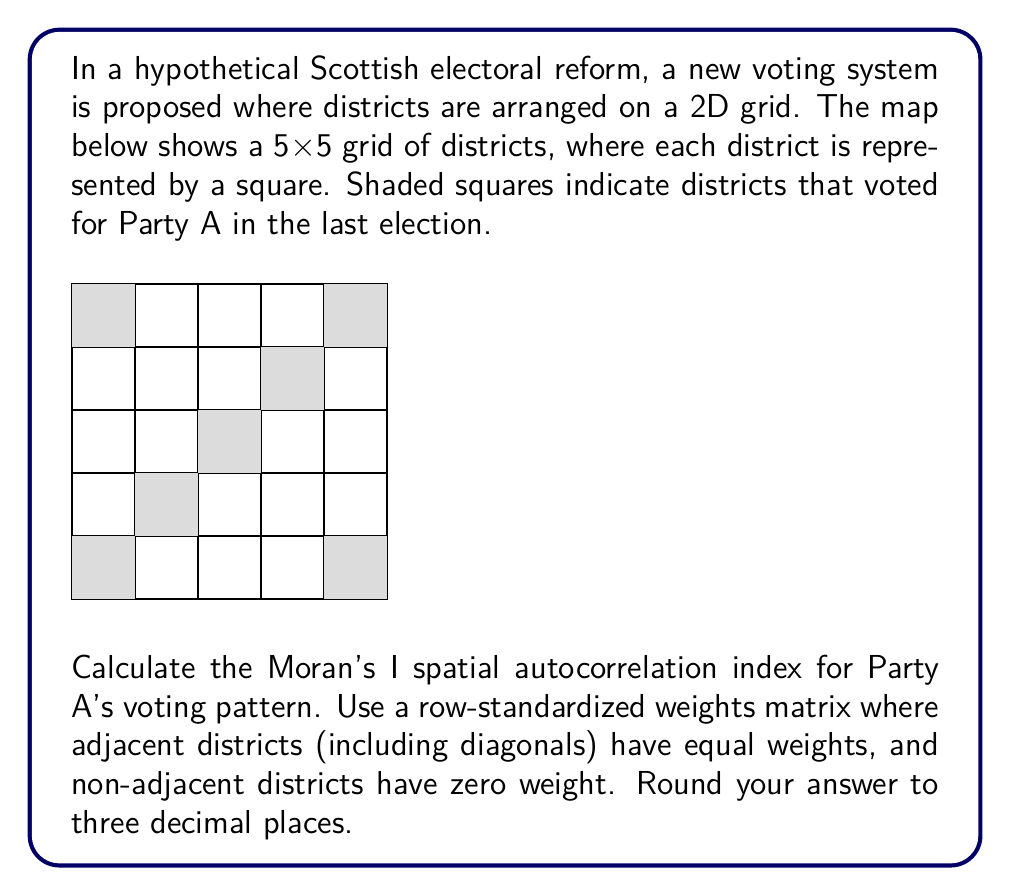Help me with this question. To calculate Moran's I, we'll follow these steps:

1) First, we need to create a binary variable for each district: 1 if it voted for Party A, 0 otherwise.

2) Calculate the mean of this variable:
   $\bar{y} = \frac{7}{25} = 0.28$ (7 shaded squares out of 25 total)

3) Create the weights matrix. For each district, adjacent districts (including diagonals) have equal weights that sum to 1, and non-adjacent districts have 0 weight.

4) Calculate Moran's I using the formula:

   $$I = \frac{N}{\sum_{i}\sum_{j}w_{ij}} \cdot \frac{\sum_{i}\sum_{j}w_{ij}(y_i-\bar{y})(y_j-\bar{y})}{\sum_{i}(y_i-\bar{y})^2}$$

   where $N$ is the number of districts, $w_{ij}$ is the weight between districts $i$ and $j$, and $y_i$ is the value for district $i$.

5) Calculate each component:
   - $N = 25$
   - $\sum_{i}\sum_{j}w_{ij} = 25$ (since weights for each district sum to 1)
   - $\sum_{i}(y_i-\bar{y})^2 = 7(1-0.28)^2 + 18(0-0.28)^2 = 3.6456$

6) Calculate $\sum_{i}\sum_{j}w_{ij}(y_i-\bar{y})(y_j-\bar{y})$:
   For each shaded square, count how many of its neighbors are also shaded:
   - Corner squares (2): 1 neighbor each
   - Central square: 4 neighbors
   - Other squares (4): 2 neighbors each
   
   $(1-0.28)(1-0.28)[2(1/8) + 4(1/8) + 4(1/4)] = 0.5184 \cdot 2 = 1.0368$

7) Put it all together:
   $$I = \frac{25}{25} \cdot \frac{1.0368}{3.6456} = 0.2844$$

8) Rounding to three decimal places: 0.284
Answer: 0.284 